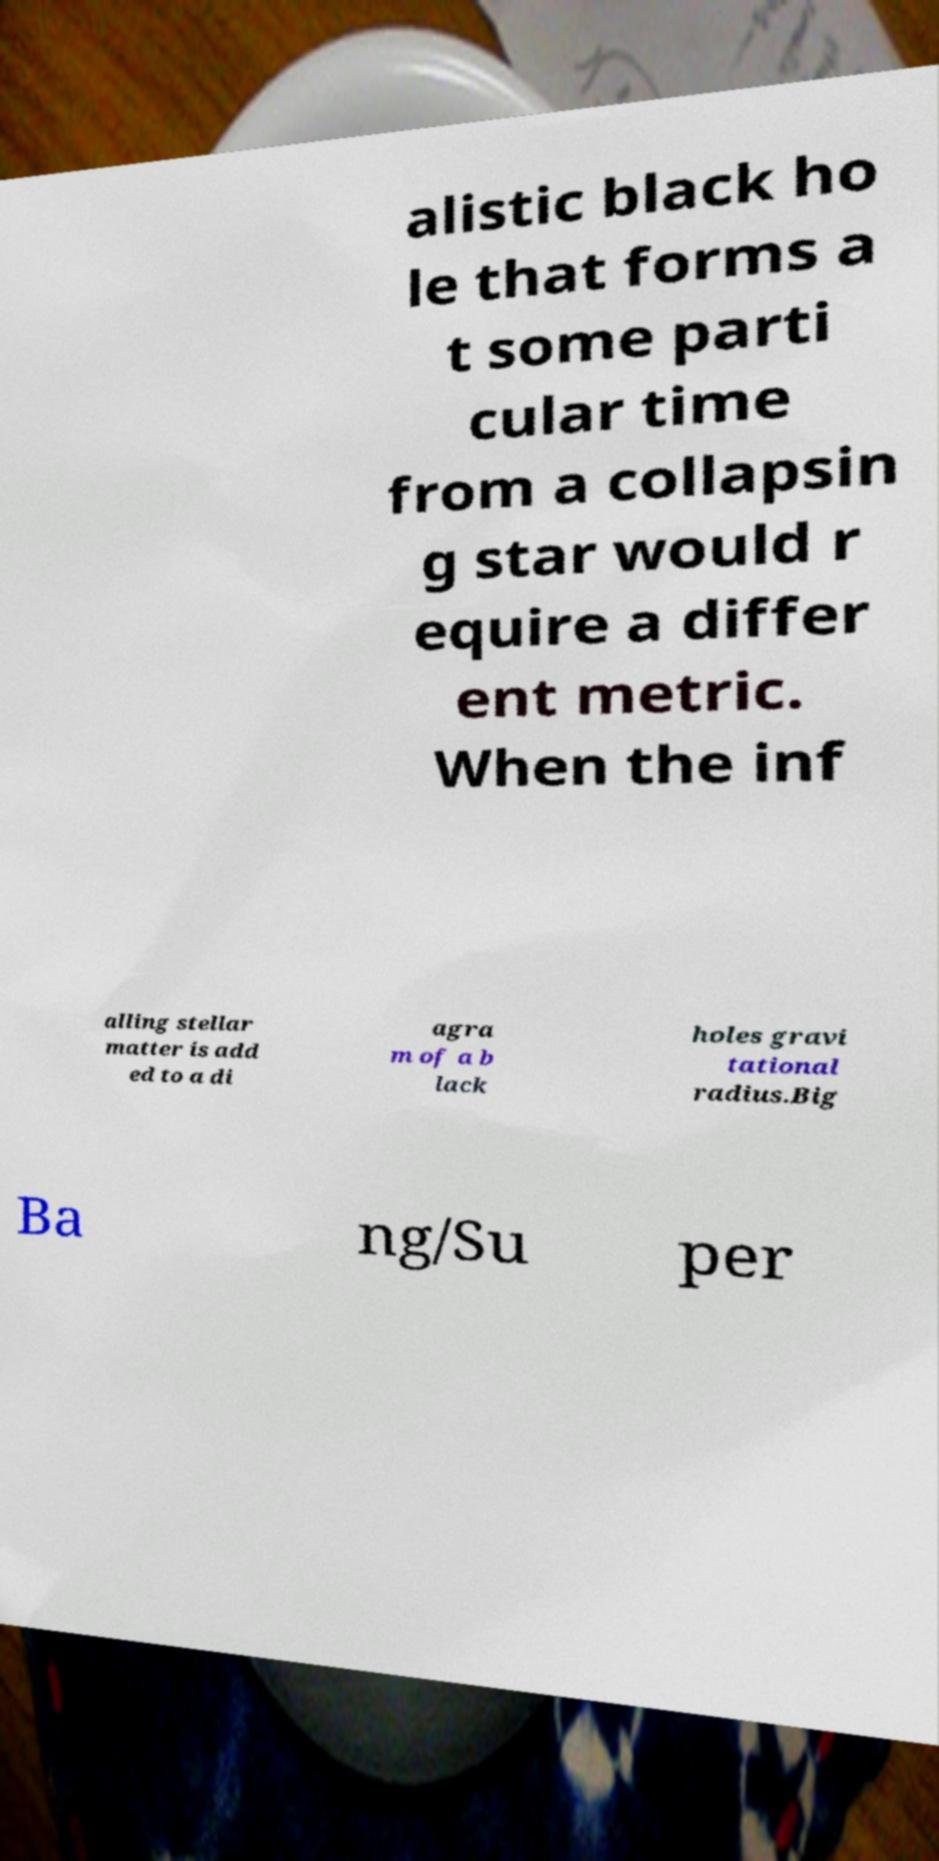Could you assist in decoding the text presented in this image and type it out clearly? alistic black ho le that forms a t some parti cular time from a collapsin g star would r equire a differ ent metric. When the inf alling stellar matter is add ed to a di agra m of a b lack holes gravi tational radius.Big Ba ng/Su per 